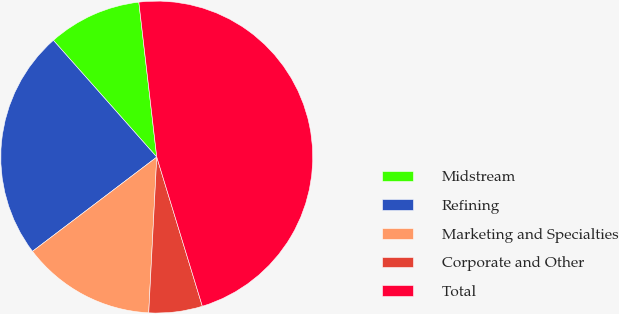Convert chart to OTSL. <chart><loc_0><loc_0><loc_500><loc_500><pie_chart><fcel>Midstream<fcel>Refining<fcel>Marketing and Specialties<fcel>Corporate and Other<fcel>Total<nl><fcel>9.7%<fcel>23.79%<fcel>13.85%<fcel>5.54%<fcel>47.11%<nl></chart> 